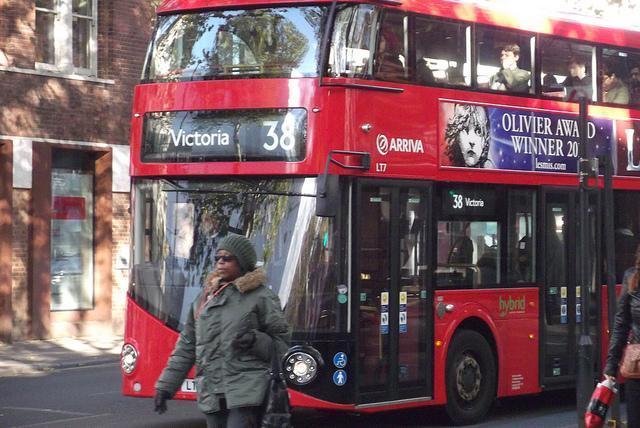How many people can you see?
Give a very brief answer. 2. 